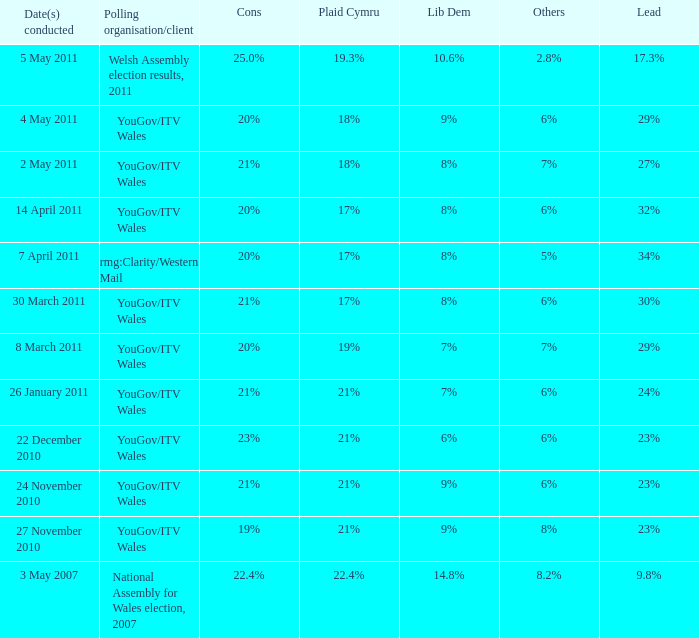What is the downside for lib dem having 8% and leading by 27%? 21%. 